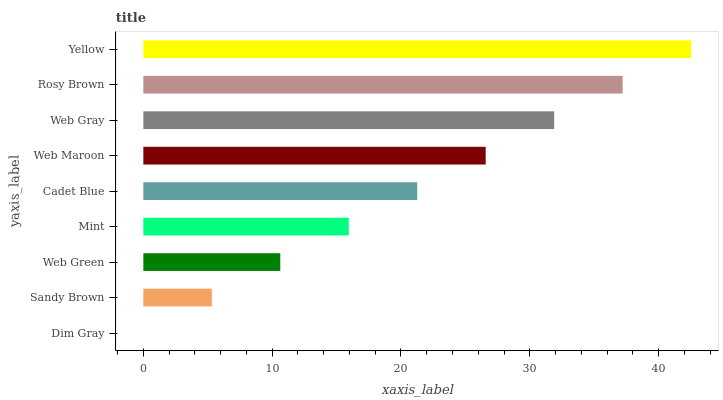Is Dim Gray the minimum?
Answer yes or no. Yes. Is Yellow the maximum?
Answer yes or no. Yes. Is Sandy Brown the minimum?
Answer yes or no. No. Is Sandy Brown the maximum?
Answer yes or no. No. Is Sandy Brown greater than Dim Gray?
Answer yes or no. Yes. Is Dim Gray less than Sandy Brown?
Answer yes or no. Yes. Is Dim Gray greater than Sandy Brown?
Answer yes or no. No. Is Sandy Brown less than Dim Gray?
Answer yes or no. No. Is Cadet Blue the high median?
Answer yes or no. Yes. Is Cadet Blue the low median?
Answer yes or no. Yes. Is Yellow the high median?
Answer yes or no. No. Is Mint the low median?
Answer yes or no. No. 